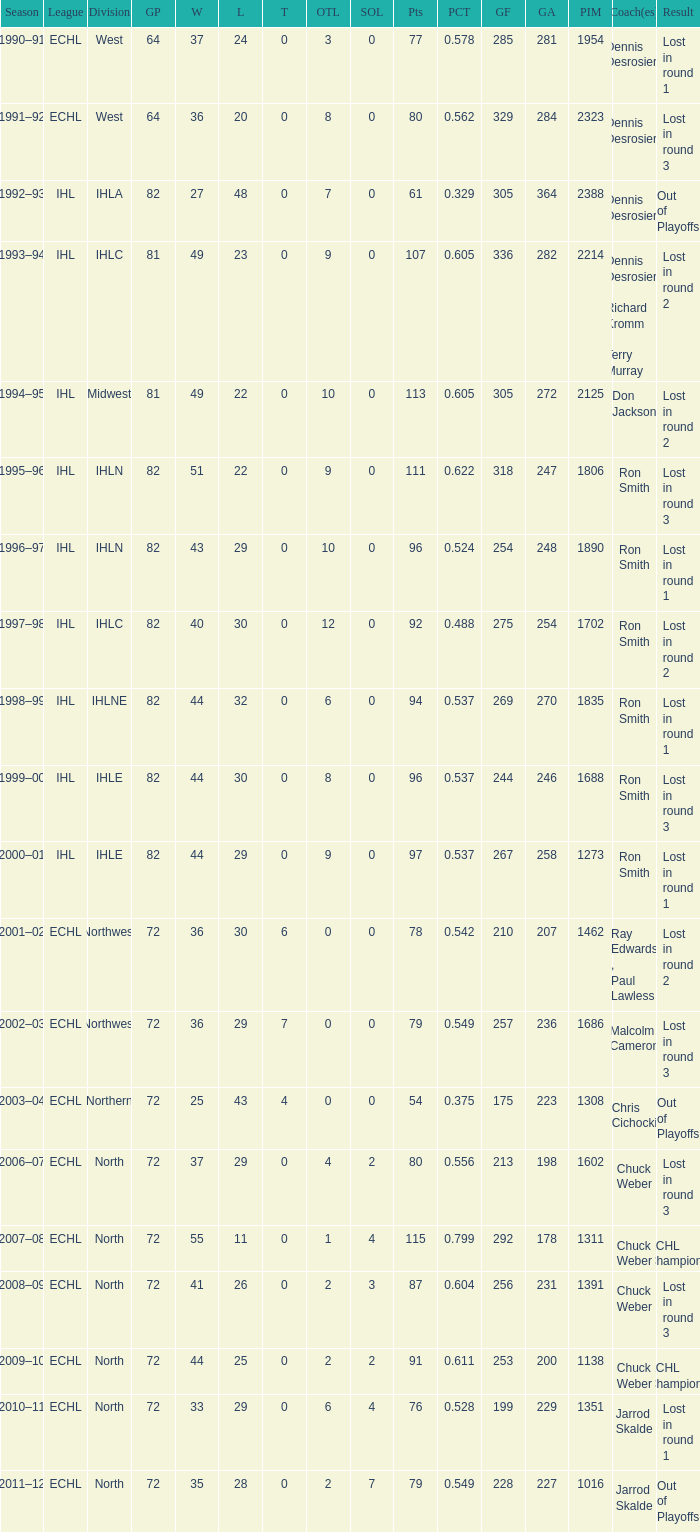How many season did the team lost in round 1 with a GP of 64? 1.0. 